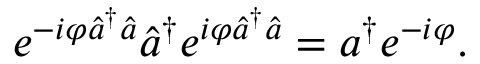<formula> <loc_0><loc_0><loc_500><loc_500>e ^ { - i \varphi \hat { a } ^ { \dagger } \hat { a } } \hat { a } ^ { \dagger } e ^ { i \varphi \hat { a } ^ { \dagger } \hat { a } } = a ^ { \dagger } e ^ { - i \varphi } .</formula> 